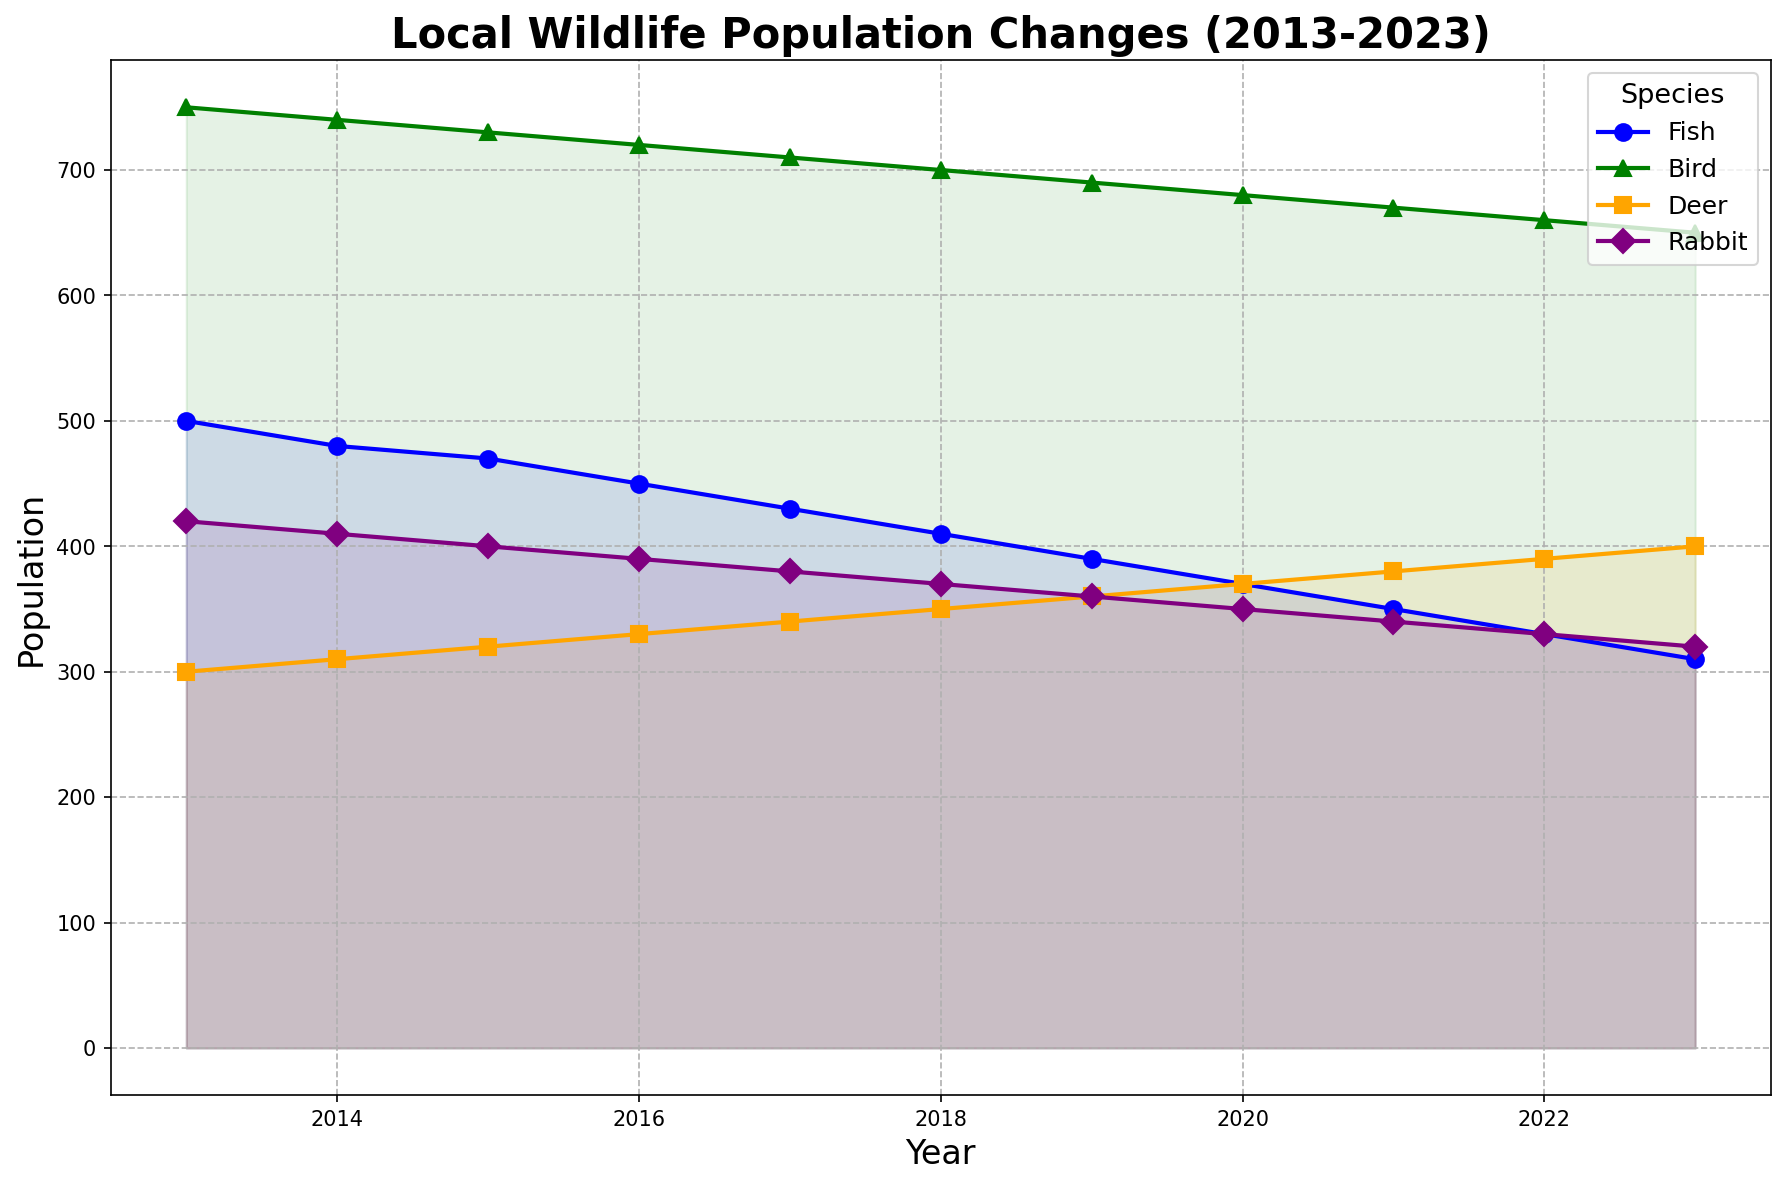Which species shows the greatest decline in population over the decade? The highest decline can be found by comparing the starting and ending population values for each species. Fish: 500-310=190, Bird: 750-650=100, Deer: 300-400=-100 (increase), Rabbit: 420-320=100. Fish has the largest decline of 190.
Answer: Fish In which year did the Bird population experience the smallest drop compared to the previous year? By examining the Bird line segment slopes, the smallest change in population was during the 2013-2014 period where the population only dropped by 10 (750 to 740). In other years, the population drops by 10 each year as well, but 2013-2014 is the first occurrence.
Answer: 2014 Across all species, which year had the lowest combined population? Summing the populations across all species for each year, 2023 has the lowest combined population with Fish: 310, Bird: 650, Deer: 400, Rabbit: 320, totaling 1680.
Answer: 2023 By how many units does the Deer population increase from 2013 to 2023? The Deer population in 2013 is 300 and in 2023 it's 400. The increase is calculated as 400 - 300 = 100.
Answer: 100 Which species had the most stable population throughout the decade? The stability can be assessed by looking at the smoothness or least variation in their population trend. Deer shows a consistently increasing trend with fewer ups and downs compared to other species.
Answer: Deer Which species had their population drop by half at any point during the decade? The Fish population drops from 500 to 250, which is a 50% decline. No other species demonstrates such a drop.
Answer: Fish During which period did the Rabbit population decline the fastest? The sharpest decline for Rabbit is from 2013 (420) to 2014 (410), continuing to drop but at a decreasing rate over subsequent years.
Answer: 2013-2014 Which two species have converging population trends? Fish and Rabbit populations both show a steady downward trend, indicating they are converging compared to others.
Answer: Fish and Rabbit During which year did the Fish population first fall below the Deer population? In 2019, the Fish population (390) first falls below the Deer population (360).
Answer: 2019 